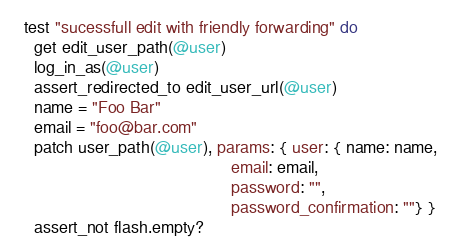Convert code to text. <code><loc_0><loc_0><loc_500><loc_500><_Ruby_>  test "sucessfull edit with friendly forwarding" do
    get edit_user_path(@user)
    log_in_as(@user)
    assert_redirected_to edit_user_url(@user)
    name = "Foo Bar"
    email = "foo@bar.com"
    patch user_path(@user), params: { user: { name: name,
                                              email: email,
                                              password: "",
                                              password_confirmation: ""} }
    assert_not flash.empty?</code> 